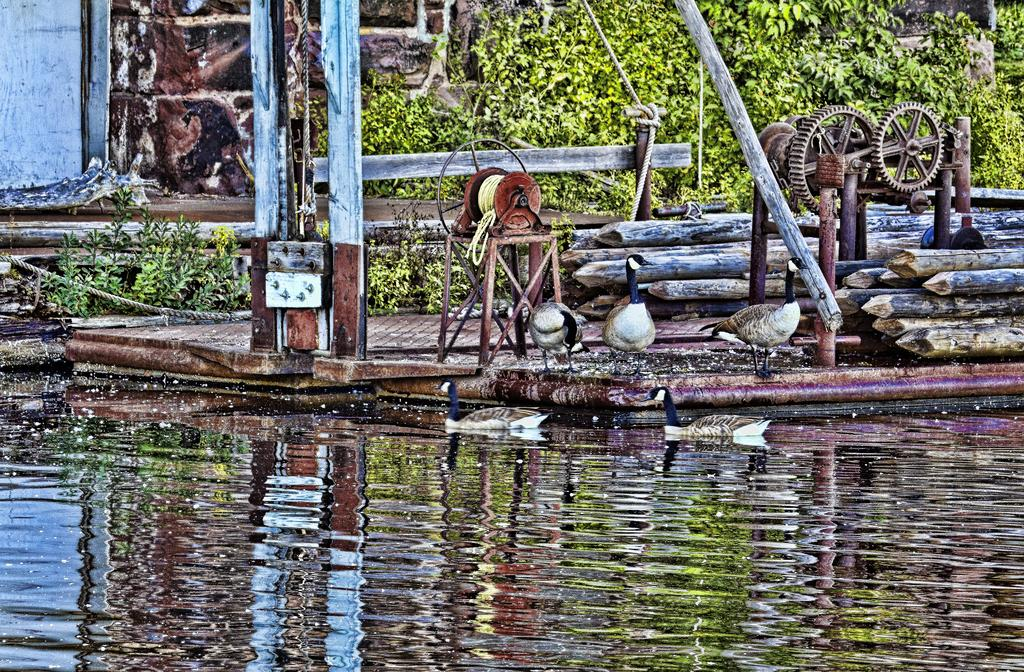What is the primary element present in the image? There is water in the image. What type of surface are the birds standing on? The birds are on a wooden floor. What can be seen attached to the wooden floor? There are two wheels visible in the image. What can be seen in the background of the image? There are plants and a wall visible in the background of the image. Who is the top achiever in the competition shown in the image? There is no competition present in the image. 